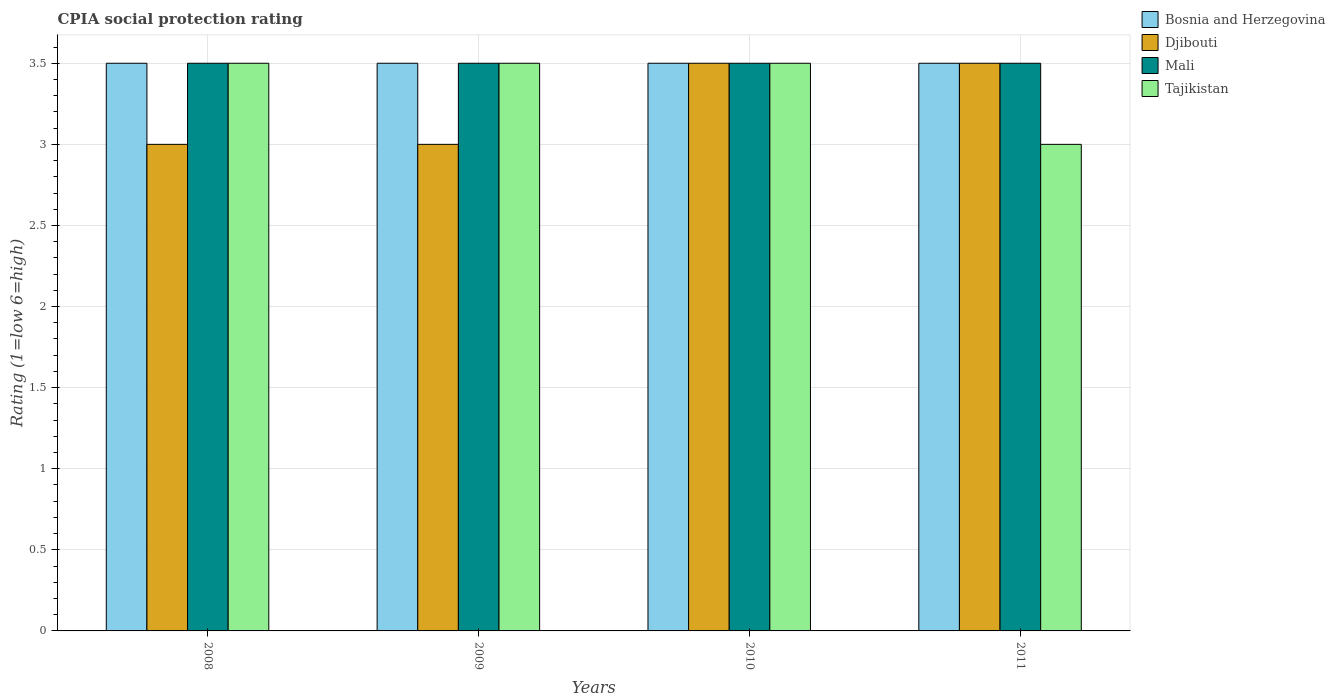Are the number of bars per tick equal to the number of legend labels?
Offer a very short reply. Yes. Are the number of bars on each tick of the X-axis equal?
Keep it short and to the point. Yes. How many bars are there on the 2nd tick from the right?
Keep it short and to the point. 4. In how many cases, is the number of bars for a given year not equal to the number of legend labels?
Keep it short and to the point. 0. What is the CPIA rating in Bosnia and Herzegovina in 2011?
Offer a terse response. 3.5. Across all years, what is the maximum CPIA rating in Mali?
Ensure brevity in your answer.  3.5. In which year was the CPIA rating in Bosnia and Herzegovina maximum?
Ensure brevity in your answer.  2008. In which year was the CPIA rating in Bosnia and Herzegovina minimum?
Provide a short and direct response. 2008. What is the difference between the CPIA rating in Mali in 2011 and the CPIA rating in Tajikistan in 2008?
Provide a succinct answer. 0. What is the average CPIA rating in Bosnia and Herzegovina per year?
Your answer should be compact. 3.5. In the year 2010, what is the difference between the CPIA rating in Bosnia and Herzegovina and CPIA rating in Djibouti?
Your response must be concise. 0. What is the ratio of the CPIA rating in Mali in 2010 to that in 2011?
Provide a succinct answer. 1. In how many years, is the CPIA rating in Bosnia and Herzegovina greater than the average CPIA rating in Bosnia and Herzegovina taken over all years?
Give a very brief answer. 0. Is the sum of the CPIA rating in Tajikistan in 2009 and 2011 greater than the maximum CPIA rating in Mali across all years?
Keep it short and to the point. Yes. What does the 4th bar from the left in 2009 represents?
Your response must be concise. Tajikistan. What does the 2nd bar from the right in 2009 represents?
Offer a very short reply. Mali. Are all the bars in the graph horizontal?
Keep it short and to the point. No. How many years are there in the graph?
Keep it short and to the point. 4. Are the values on the major ticks of Y-axis written in scientific E-notation?
Give a very brief answer. No. Does the graph contain any zero values?
Give a very brief answer. No. Where does the legend appear in the graph?
Your answer should be compact. Top right. How are the legend labels stacked?
Your answer should be very brief. Vertical. What is the title of the graph?
Give a very brief answer. CPIA social protection rating. Does "China" appear as one of the legend labels in the graph?
Offer a terse response. No. What is the Rating (1=low 6=high) of Djibouti in 2008?
Offer a very short reply. 3. What is the Rating (1=low 6=high) of Mali in 2008?
Offer a terse response. 3.5. What is the Rating (1=low 6=high) of Mali in 2010?
Provide a succinct answer. 3.5. What is the Rating (1=low 6=high) in Mali in 2011?
Give a very brief answer. 3.5. Across all years, what is the maximum Rating (1=low 6=high) in Mali?
Make the answer very short. 3.5. Across all years, what is the maximum Rating (1=low 6=high) in Tajikistan?
Ensure brevity in your answer.  3.5. Across all years, what is the minimum Rating (1=low 6=high) of Bosnia and Herzegovina?
Provide a succinct answer. 3.5. Across all years, what is the minimum Rating (1=low 6=high) of Mali?
Ensure brevity in your answer.  3.5. What is the total Rating (1=low 6=high) in Bosnia and Herzegovina in the graph?
Offer a terse response. 14. What is the total Rating (1=low 6=high) in Mali in the graph?
Your answer should be very brief. 14. What is the total Rating (1=low 6=high) of Tajikistan in the graph?
Your answer should be compact. 13.5. What is the difference between the Rating (1=low 6=high) in Bosnia and Herzegovina in 2008 and that in 2009?
Your answer should be very brief. 0. What is the difference between the Rating (1=low 6=high) of Djibouti in 2008 and that in 2009?
Make the answer very short. 0. What is the difference between the Rating (1=low 6=high) of Bosnia and Herzegovina in 2008 and that in 2010?
Provide a succinct answer. 0. What is the difference between the Rating (1=low 6=high) in Mali in 2008 and that in 2011?
Provide a succinct answer. 0. What is the difference between the Rating (1=low 6=high) in Tajikistan in 2008 and that in 2011?
Provide a short and direct response. 0.5. What is the difference between the Rating (1=low 6=high) of Bosnia and Herzegovina in 2009 and that in 2010?
Offer a terse response. 0. What is the difference between the Rating (1=low 6=high) in Mali in 2009 and that in 2010?
Provide a succinct answer. 0. What is the difference between the Rating (1=low 6=high) of Djibouti in 2009 and that in 2011?
Ensure brevity in your answer.  -0.5. What is the difference between the Rating (1=low 6=high) in Mali in 2009 and that in 2011?
Ensure brevity in your answer.  0. What is the difference between the Rating (1=low 6=high) in Tajikistan in 2009 and that in 2011?
Ensure brevity in your answer.  0.5. What is the difference between the Rating (1=low 6=high) in Bosnia and Herzegovina in 2010 and that in 2011?
Your answer should be very brief. 0. What is the difference between the Rating (1=low 6=high) of Djibouti in 2010 and that in 2011?
Offer a very short reply. 0. What is the difference between the Rating (1=low 6=high) in Tajikistan in 2010 and that in 2011?
Provide a succinct answer. 0.5. What is the difference between the Rating (1=low 6=high) in Djibouti in 2008 and the Rating (1=low 6=high) in Mali in 2009?
Make the answer very short. -0.5. What is the difference between the Rating (1=low 6=high) in Mali in 2008 and the Rating (1=low 6=high) in Tajikistan in 2009?
Provide a short and direct response. 0. What is the difference between the Rating (1=low 6=high) in Bosnia and Herzegovina in 2008 and the Rating (1=low 6=high) in Djibouti in 2010?
Your response must be concise. 0. What is the difference between the Rating (1=low 6=high) in Djibouti in 2008 and the Rating (1=low 6=high) in Mali in 2010?
Give a very brief answer. -0.5. What is the difference between the Rating (1=low 6=high) in Bosnia and Herzegovina in 2008 and the Rating (1=low 6=high) in Mali in 2011?
Make the answer very short. 0. What is the difference between the Rating (1=low 6=high) of Bosnia and Herzegovina in 2008 and the Rating (1=low 6=high) of Tajikistan in 2011?
Provide a short and direct response. 0.5. What is the difference between the Rating (1=low 6=high) of Djibouti in 2008 and the Rating (1=low 6=high) of Mali in 2011?
Ensure brevity in your answer.  -0.5. What is the difference between the Rating (1=low 6=high) of Mali in 2008 and the Rating (1=low 6=high) of Tajikistan in 2011?
Make the answer very short. 0.5. What is the difference between the Rating (1=low 6=high) in Bosnia and Herzegovina in 2009 and the Rating (1=low 6=high) in Djibouti in 2010?
Your response must be concise. 0. What is the difference between the Rating (1=low 6=high) in Bosnia and Herzegovina in 2009 and the Rating (1=low 6=high) in Tajikistan in 2010?
Ensure brevity in your answer.  0. What is the difference between the Rating (1=low 6=high) of Djibouti in 2009 and the Rating (1=low 6=high) of Mali in 2010?
Provide a short and direct response. -0.5. What is the difference between the Rating (1=low 6=high) of Mali in 2009 and the Rating (1=low 6=high) of Tajikistan in 2010?
Your answer should be very brief. 0. What is the difference between the Rating (1=low 6=high) of Bosnia and Herzegovina in 2009 and the Rating (1=low 6=high) of Djibouti in 2011?
Provide a succinct answer. 0. What is the difference between the Rating (1=low 6=high) of Bosnia and Herzegovina in 2009 and the Rating (1=low 6=high) of Mali in 2011?
Ensure brevity in your answer.  0. What is the difference between the Rating (1=low 6=high) in Bosnia and Herzegovina in 2009 and the Rating (1=low 6=high) in Tajikistan in 2011?
Your response must be concise. 0.5. What is the difference between the Rating (1=low 6=high) of Djibouti in 2009 and the Rating (1=low 6=high) of Mali in 2011?
Offer a terse response. -0.5. What is the difference between the Rating (1=low 6=high) of Djibouti in 2009 and the Rating (1=low 6=high) of Tajikistan in 2011?
Provide a short and direct response. 0. What is the difference between the Rating (1=low 6=high) of Mali in 2009 and the Rating (1=low 6=high) of Tajikistan in 2011?
Ensure brevity in your answer.  0.5. What is the difference between the Rating (1=low 6=high) in Djibouti in 2010 and the Rating (1=low 6=high) in Mali in 2011?
Give a very brief answer. 0. What is the difference between the Rating (1=low 6=high) of Djibouti in 2010 and the Rating (1=low 6=high) of Tajikistan in 2011?
Ensure brevity in your answer.  0.5. What is the average Rating (1=low 6=high) in Tajikistan per year?
Keep it short and to the point. 3.38. In the year 2008, what is the difference between the Rating (1=low 6=high) in Bosnia and Herzegovina and Rating (1=low 6=high) in Mali?
Give a very brief answer. 0. In the year 2008, what is the difference between the Rating (1=low 6=high) of Mali and Rating (1=low 6=high) of Tajikistan?
Offer a terse response. 0. In the year 2009, what is the difference between the Rating (1=low 6=high) of Bosnia and Herzegovina and Rating (1=low 6=high) of Tajikistan?
Offer a terse response. 0. In the year 2009, what is the difference between the Rating (1=low 6=high) of Djibouti and Rating (1=low 6=high) of Mali?
Your answer should be very brief. -0.5. In the year 2009, what is the difference between the Rating (1=low 6=high) of Mali and Rating (1=low 6=high) of Tajikistan?
Ensure brevity in your answer.  0. In the year 2010, what is the difference between the Rating (1=low 6=high) of Bosnia and Herzegovina and Rating (1=low 6=high) of Djibouti?
Offer a terse response. 0. In the year 2010, what is the difference between the Rating (1=low 6=high) of Djibouti and Rating (1=low 6=high) of Tajikistan?
Keep it short and to the point. 0. In the year 2011, what is the difference between the Rating (1=low 6=high) of Djibouti and Rating (1=low 6=high) of Mali?
Your answer should be compact. 0. In the year 2011, what is the difference between the Rating (1=low 6=high) in Djibouti and Rating (1=low 6=high) in Tajikistan?
Make the answer very short. 0.5. What is the ratio of the Rating (1=low 6=high) of Bosnia and Herzegovina in 2008 to that in 2009?
Provide a succinct answer. 1. What is the ratio of the Rating (1=low 6=high) in Djibouti in 2008 to that in 2009?
Make the answer very short. 1. What is the ratio of the Rating (1=low 6=high) of Bosnia and Herzegovina in 2008 to that in 2010?
Give a very brief answer. 1. What is the ratio of the Rating (1=low 6=high) in Djibouti in 2008 to that in 2010?
Ensure brevity in your answer.  0.86. What is the ratio of the Rating (1=low 6=high) of Mali in 2008 to that in 2010?
Give a very brief answer. 1. What is the ratio of the Rating (1=low 6=high) in Djibouti in 2008 to that in 2011?
Your answer should be compact. 0.86. What is the ratio of the Rating (1=low 6=high) of Djibouti in 2009 to that in 2010?
Your answer should be compact. 0.86. What is the ratio of the Rating (1=low 6=high) in Bosnia and Herzegovina in 2009 to that in 2011?
Make the answer very short. 1. What is the ratio of the Rating (1=low 6=high) in Djibouti in 2009 to that in 2011?
Make the answer very short. 0.86. What is the ratio of the Rating (1=low 6=high) in Djibouti in 2010 to that in 2011?
Your answer should be very brief. 1. What is the difference between the highest and the second highest Rating (1=low 6=high) in Bosnia and Herzegovina?
Ensure brevity in your answer.  0. What is the difference between the highest and the lowest Rating (1=low 6=high) in Bosnia and Herzegovina?
Your answer should be very brief. 0. What is the difference between the highest and the lowest Rating (1=low 6=high) of Mali?
Your response must be concise. 0. What is the difference between the highest and the lowest Rating (1=low 6=high) in Tajikistan?
Your response must be concise. 0.5. 